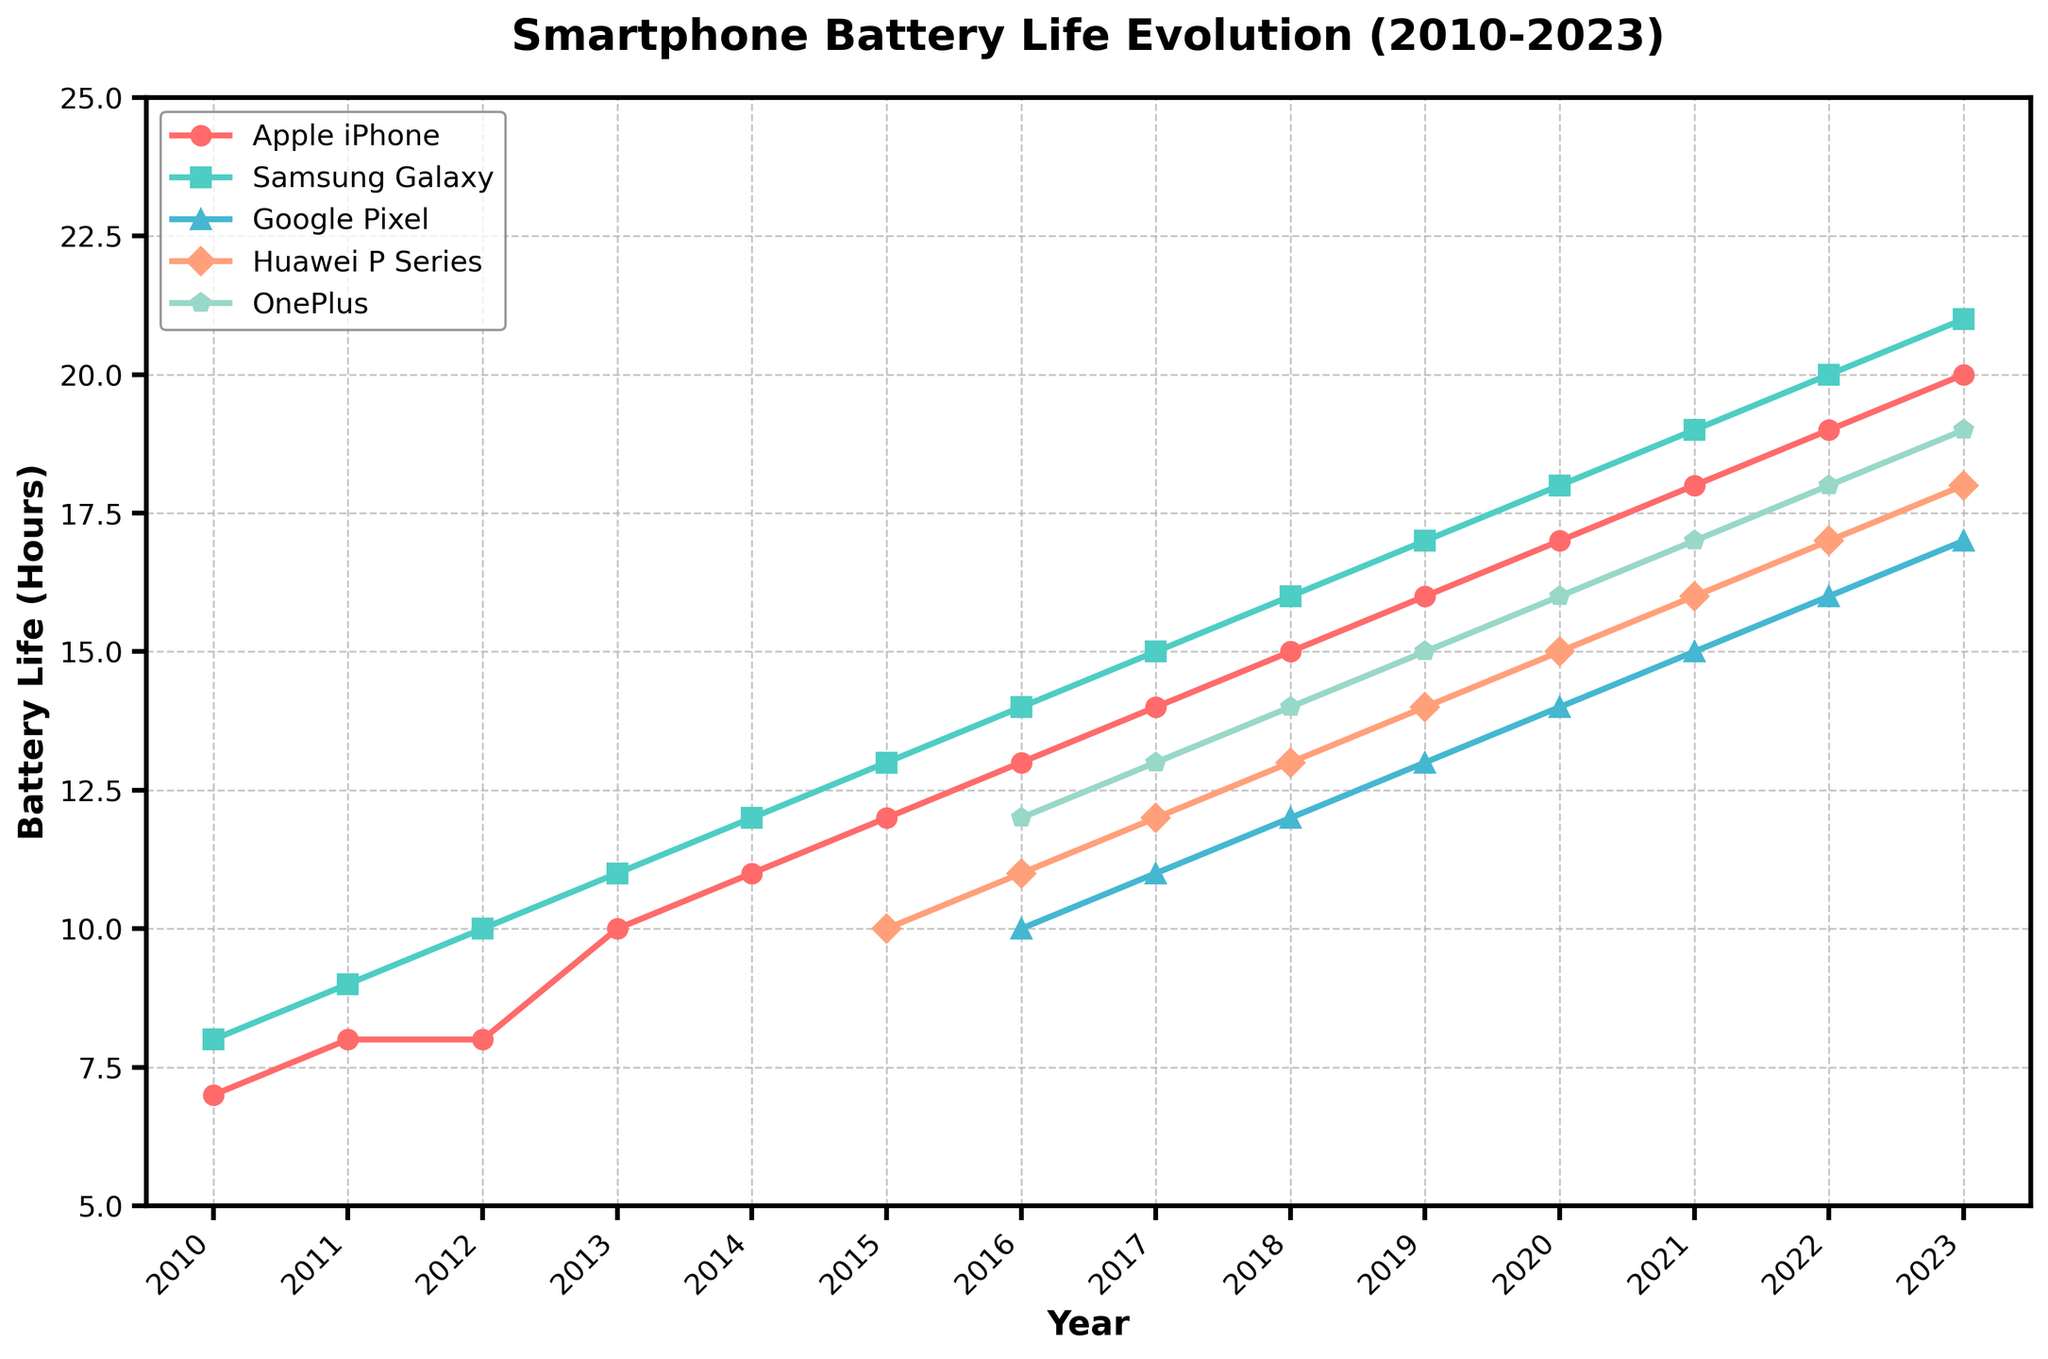Which smartphone brand showed the greatest increase in battery life from 2010 to 2023? To find the answer, calculate the difference between the battery life values in 2023 and 2010 for each brand. Apple iPhone: 20-7=13 hours, Samsung Galaxy: 21-8=13 hours, Google Pixel: not present in 2010, Huawei P Series: not present in 2010, OnePlus: not present in 2010. Both Apple iPhone and Samsung Galaxy showed an increase of 13 hours.
Answer: Apple iPhone and Samsung Galaxy In which year did Huawei P Series start appearing in the data? Check the first year where Huawei P Series has a value other than missing. The first non-blank value for Huawei P Series appears in 2015.
Answer: 2015 Which brand had the longest battery life in 2016? Look at the battery life values in the year 2016 for all the brands. The values are: Apple iPhone: 13, Samsung Galaxy: 14, Google Pixel: 10, Huawei P Series: 11, OnePlus: 12. Samsung Galaxy had the highest value.
Answer: Samsung Galaxy What is the average battery life of Google Pixel from 2016 to 2023? Sum the battery life values of Google Pixel from 2016 to 2023 and then divide by the number of years. (10+11+12+13+14+15+16+17) / 8 = 108 / 8 = 13.5 hours
Answer: 13.5 hours Which brand had the smallest battery life in 2022? Check the battery life values in 2022 for all the brands. The values are: Apple iPhone: 19, Samsung Galaxy: 20, Google Pixel: 16, Huawei P Series: 17, OnePlus: 18. Google Pixel had the smallest value.
Answer: Google Pixel How much did the battery life of OnePlus increase from 2016 to 2023? Subtract the battery life value of OnePlus in 2016 from its value in 2023. 19 - 12 = 7 hours
Answer: 7 hours Between which consecutive years did Samsung Galaxy see the largest increase in battery life? Calculate the difference in Samsung Galaxy's battery life between each consecutive year: 2011-2010: 9-8=1, 2012-2011: 10-9=1, 2013-2012: 11-10=1, 2014-2013: 12-11=1, 2015-2014: 13-12=1, 2016-2015: 14-13=1, 2017-2016: 15-14=1, 2018-2017: 16-15=1, 2019-2018: 17-16=1, 2020-2019: 18-17=1, 2021-2020: 19-18=1, 2022-2021: 20-19=1, 2023-2022: 21-20=1. All consecutive years had the same increase of 1 hour.
Answer: All consecutive years had the same increase In 2020, which brand had battery life closest to the average of all brands in that year? Compute the average battery life for all brands in 2020: (17+18+14+15+16) / 5 = 80 / 5 = 16 hours. The values are: Apple iPhone: 17, Samsung Galaxy: 18, Google Pixel: 14, Huawei P Series: 15, OnePlus: 16. The closest value to 16 is for OnePlus.
Answer: OnePlus 